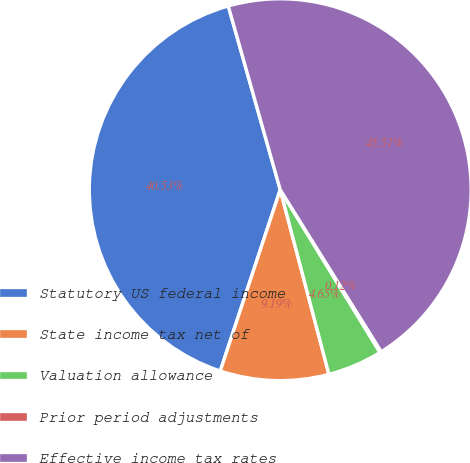Convert chart. <chart><loc_0><loc_0><loc_500><loc_500><pie_chart><fcel>Statutory US federal income<fcel>State income tax net of<fcel>Valuation allowance<fcel>Prior period adjustments<fcel>Effective income tax rates<nl><fcel>40.53%<fcel>9.19%<fcel>4.65%<fcel>0.12%<fcel>45.51%<nl></chart> 